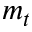<formula> <loc_0><loc_0><loc_500><loc_500>m _ { t }</formula> 